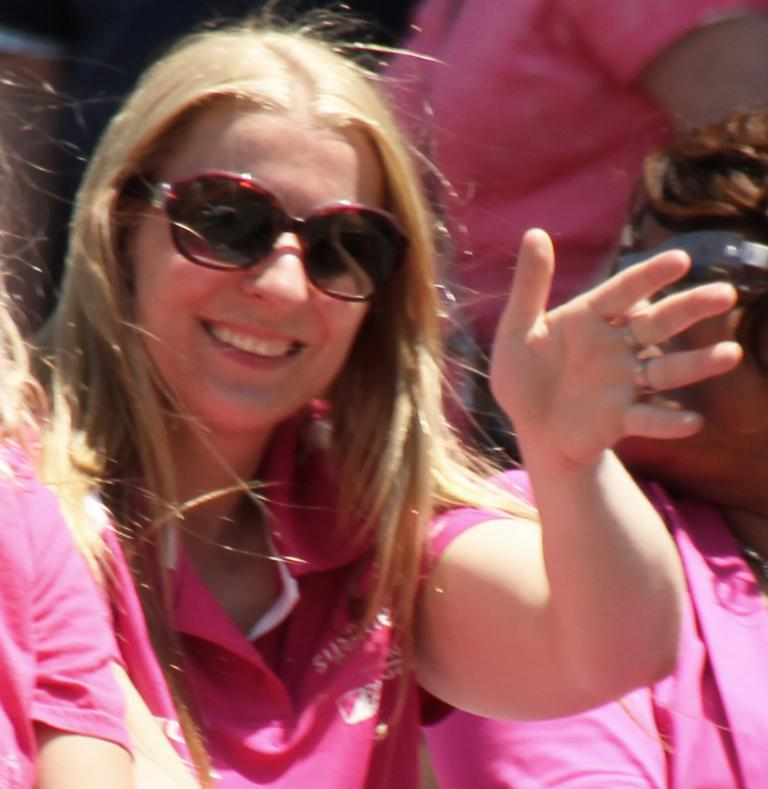Who is the main subject in the foreground of the image? There is a woman in the foreground of the image. What is the woman wearing in the image? The woman is wearing spectacles. What is the woman doing in the image? The woman is waving her hand. How many other women are present in the image? There are two other women on either side of the woman in the foreground. What can be observed about the people at the top of the image? The people at the top of the image are truncated, meaning they are partially visible. What type of mind can be seen in the image? There is no mention of a mind in the image. 